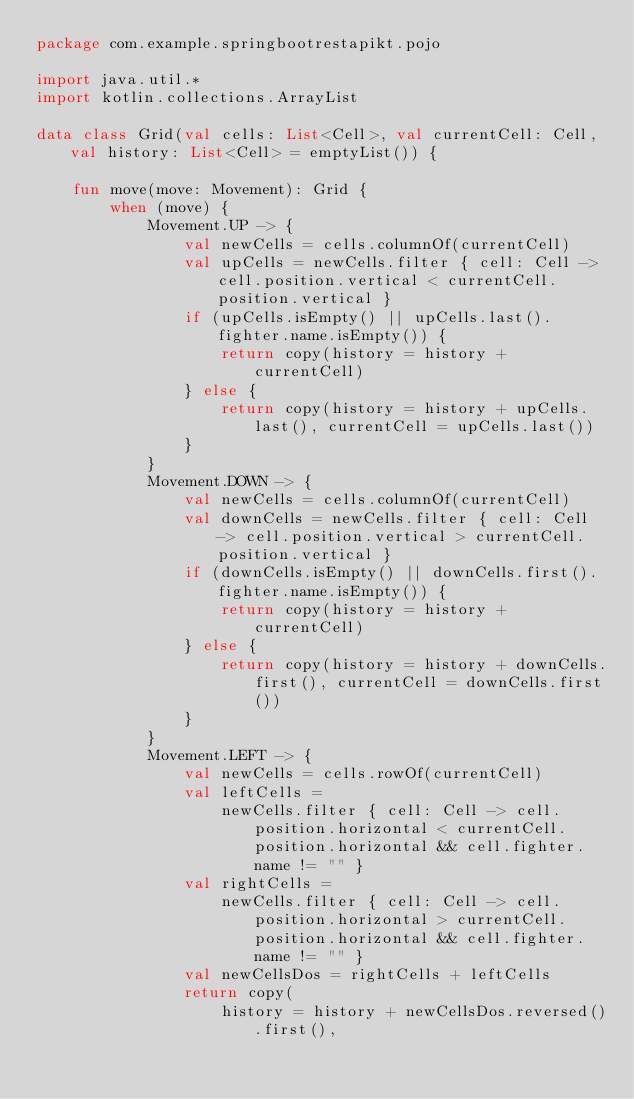Convert code to text. <code><loc_0><loc_0><loc_500><loc_500><_Kotlin_>package com.example.springbootrestapikt.pojo

import java.util.*
import kotlin.collections.ArrayList

data class Grid(val cells: List<Cell>, val currentCell: Cell, val history: List<Cell> = emptyList()) {

    fun move(move: Movement): Grid {
        when (move) {
            Movement.UP -> {
                val newCells = cells.columnOf(currentCell)
                val upCells = newCells.filter { cell: Cell -> cell.position.vertical < currentCell.position.vertical }
                if (upCells.isEmpty() || upCells.last().fighter.name.isEmpty()) {
                    return copy(history = history + currentCell)
                } else {
                    return copy(history = history + upCells.last(), currentCell = upCells.last())
                }
            }
            Movement.DOWN -> {
                val newCells = cells.columnOf(currentCell)
                val downCells = newCells.filter { cell: Cell -> cell.position.vertical > currentCell.position.vertical }
                if (downCells.isEmpty() || downCells.first().fighter.name.isEmpty()) {
                    return copy(history = history + currentCell)
                } else {
                    return copy(history = history + downCells.first(), currentCell = downCells.first())
                }
            }
            Movement.LEFT -> {
                val newCells = cells.rowOf(currentCell)
                val leftCells =
                    newCells.filter { cell: Cell -> cell.position.horizontal < currentCell.position.horizontal && cell.fighter.name != "" }
                val rightCells =
                    newCells.filter { cell: Cell -> cell.position.horizontal > currentCell.position.horizontal && cell.fighter.name != "" }
                val newCellsDos = rightCells + leftCells
                return copy(
                    history = history + newCellsDos.reversed().first(),</code> 